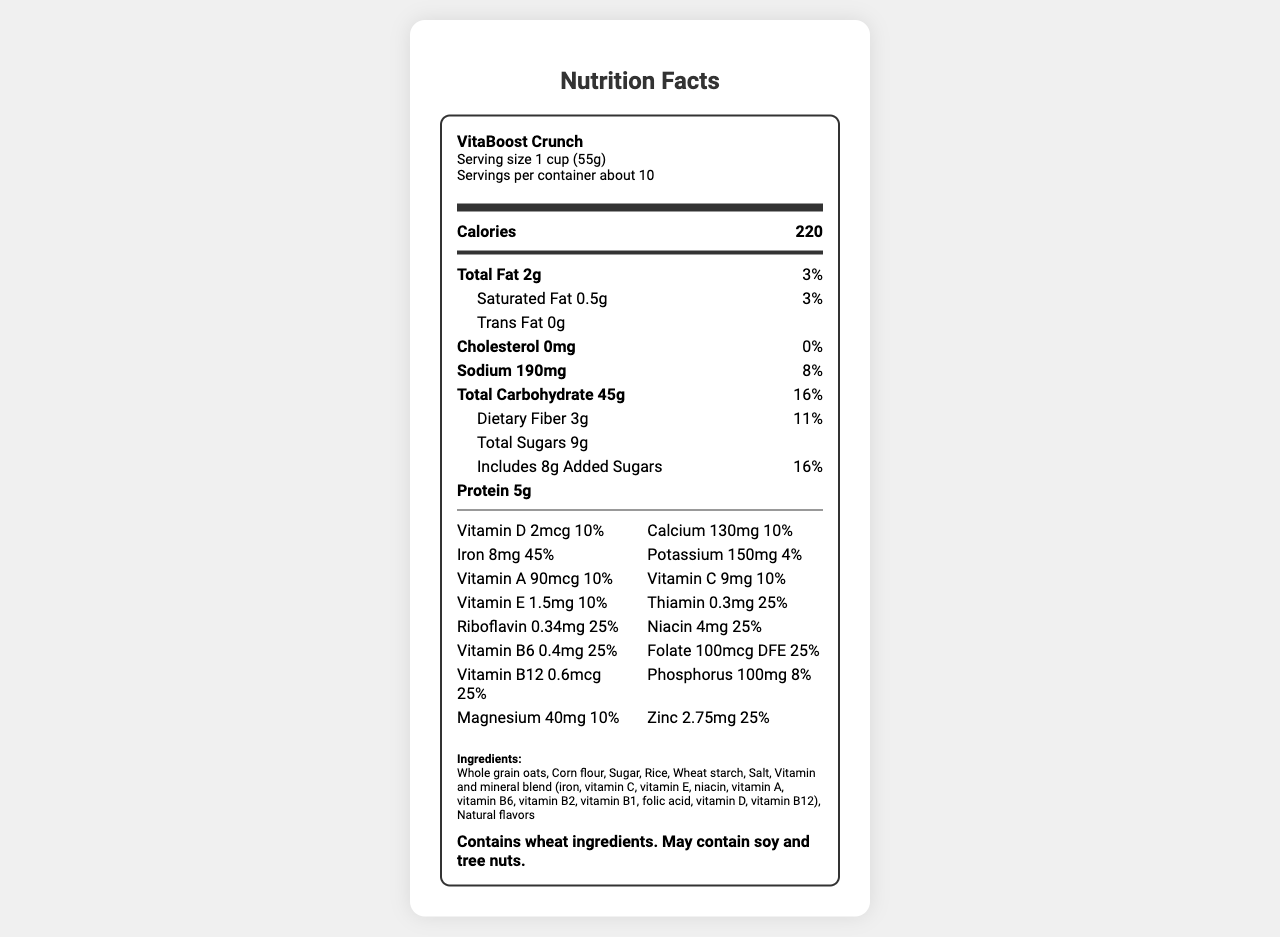what is the name of the product? The product name is explicitly stated at the beginning of the document as "VitaBoost Crunch".
Answer: VitaBoost Crunch how many servings are in the container? The servings per container are listed as "about 10" in the document.
Answer: about 10 how much total fat is in a serving? The document lists "Total Fat" as 2g per serving.
Answer: 2g how much iron does the cereal provide per serving? Under the "vitamins" section, it explicitly states that Iron is 8mg per serving.
Answer: 8mg what is the daily value percentage of calcium? The daily value of calcium is listed as 10% in the document.
Answer: 10% what allergens does the product contain? The allergen information section states that the product "Contains wheat ingredients. May contain soy and tree nuts."
Answer: Contains wheat ingredients. May contain soy and tree nuts. does the cereal contain any vitamin B12? The vitamins section lists Vitamin B12 content as 0.6mcg, which is confirmed by the daily value of 25%.
Answer: Yes what is the serving size of the cereal? The document lists the serving size as "1 cup (55g)".
Answer: 1 cup (55g) who is the manufacturer of the cereal? The manufacturer's name is provided at the end of the document.
Answer: HealthyStart Foods Inc. what is the daily value percentage of added sugars? The document states that one serving includes 8g of added sugars, which corresponds to 16% of the daily value.
Answer: 16% does this product contain any trans fat? The document explicitly lists "Trans Fat" as 0g, indicating that there is no trans fat.
Answer: No which nutrient has the highest daily value percentage? (A) Vitamin D (B) Iron (C) Magnesium (D) Sodium The daily value for Iron is listed as 45%, which is the highest among the nutrients listed.
Answer: B how are consumers instructed to store the cereal? (1) Refrigerate after opening (2) Keep at room temperature (3) Store in a cool, dry place (4) Freeze to maintain freshness The document states to "Store in a cool, dry place" and "Reseal package to maintain freshness."
Answer: 3 which vitamins are included in the cereal? (I) Vitamin A, B1, D, and B12 (II) Vitamin C, E, K, and B6 (III) Vitamin A, C, E, and B6 The document lists the vitamins in the blend, including Vitamin A, B1 (Thiamin), D, and B12.
Answer: I does the product include added sugars? The document clearly mentions "Includes 8g Added Sugars".
Answer: Yes can this document tell you if the cereal is gluten-free? The document states that the product contains wheat ingredients, but it does not specifically mention whether it is gluten-free.
Answer: No describe the main focus of the document The document is focused on offering comprehensive nutrition facts and related details for VitaBoost Crunch cereal, allowing consumers to understand its nutritional content and dietary compatibility.
Answer: The document provides detailed nutritional information for a vitamin-fortified breakfast cereal called VitaBoost Crunch. It includes serving size, calories, nutrient amounts, daily value percentages, ingredient list, allergen information, and storage instructions. how much sodium is in a single serving? The document clearly lists the sodium content as 190mg per serving.
Answer: 190mg 